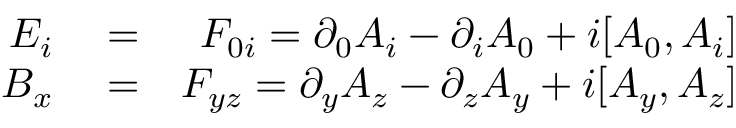<formula> <loc_0><loc_0><loc_500><loc_500>\begin{array} { r l r } { E _ { i } } & = } & { F _ { 0 i } = \partial _ { 0 } A _ { i } - \partial _ { i } A _ { 0 } + i [ A _ { 0 } , A _ { i } ] } \\ { B _ { x } } & = } & { F _ { y z } = \partial _ { y } A _ { z } - \partial _ { z } A _ { y } + i [ A _ { y } , A _ { z } ] } \end{array}</formula> 